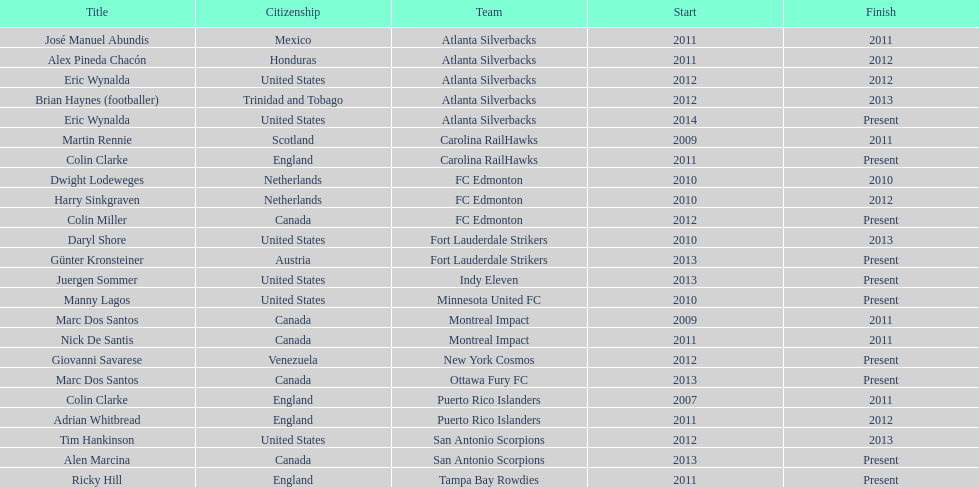How long did colin clarke coach the puerto rico islanders for? 4 years. Help me parse the entirety of this table. {'header': ['Title', 'Citizenship', 'Team', 'Start', 'Finish'], 'rows': [['José Manuel Abundis', 'Mexico', 'Atlanta Silverbacks', '2011', '2011'], ['Alex Pineda Chacón', 'Honduras', 'Atlanta Silverbacks', '2011', '2012'], ['Eric Wynalda', 'United States', 'Atlanta Silverbacks', '2012', '2012'], ['Brian Haynes (footballer)', 'Trinidad and Tobago', 'Atlanta Silverbacks', '2012', '2013'], ['Eric Wynalda', 'United States', 'Atlanta Silverbacks', '2014', 'Present'], ['Martin Rennie', 'Scotland', 'Carolina RailHawks', '2009', '2011'], ['Colin Clarke', 'England', 'Carolina RailHawks', '2011', 'Present'], ['Dwight Lodeweges', 'Netherlands', 'FC Edmonton', '2010', '2010'], ['Harry Sinkgraven', 'Netherlands', 'FC Edmonton', '2010', '2012'], ['Colin Miller', 'Canada', 'FC Edmonton', '2012', 'Present'], ['Daryl Shore', 'United States', 'Fort Lauderdale Strikers', '2010', '2013'], ['Günter Kronsteiner', 'Austria', 'Fort Lauderdale Strikers', '2013', 'Present'], ['Juergen Sommer', 'United States', 'Indy Eleven', '2013', 'Present'], ['Manny Lagos', 'United States', 'Minnesota United FC', '2010', 'Present'], ['Marc Dos Santos', 'Canada', 'Montreal Impact', '2009', '2011'], ['Nick De Santis', 'Canada', 'Montreal Impact', '2011', '2011'], ['Giovanni Savarese', 'Venezuela', 'New York Cosmos', '2012', 'Present'], ['Marc Dos Santos', 'Canada', 'Ottawa Fury FC', '2013', 'Present'], ['Colin Clarke', 'England', 'Puerto Rico Islanders', '2007', '2011'], ['Adrian Whitbread', 'England', 'Puerto Rico Islanders', '2011', '2012'], ['Tim Hankinson', 'United States', 'San Antonio Scorpions', '2012', '2013'], ['Alen Marcina', 'Canada', 'San Antonio Scorpions', '2013', 'Present'], ['Ricky Hill', 'England', 'Tampa Bay Rowdies', '2011', 'Present']]} 